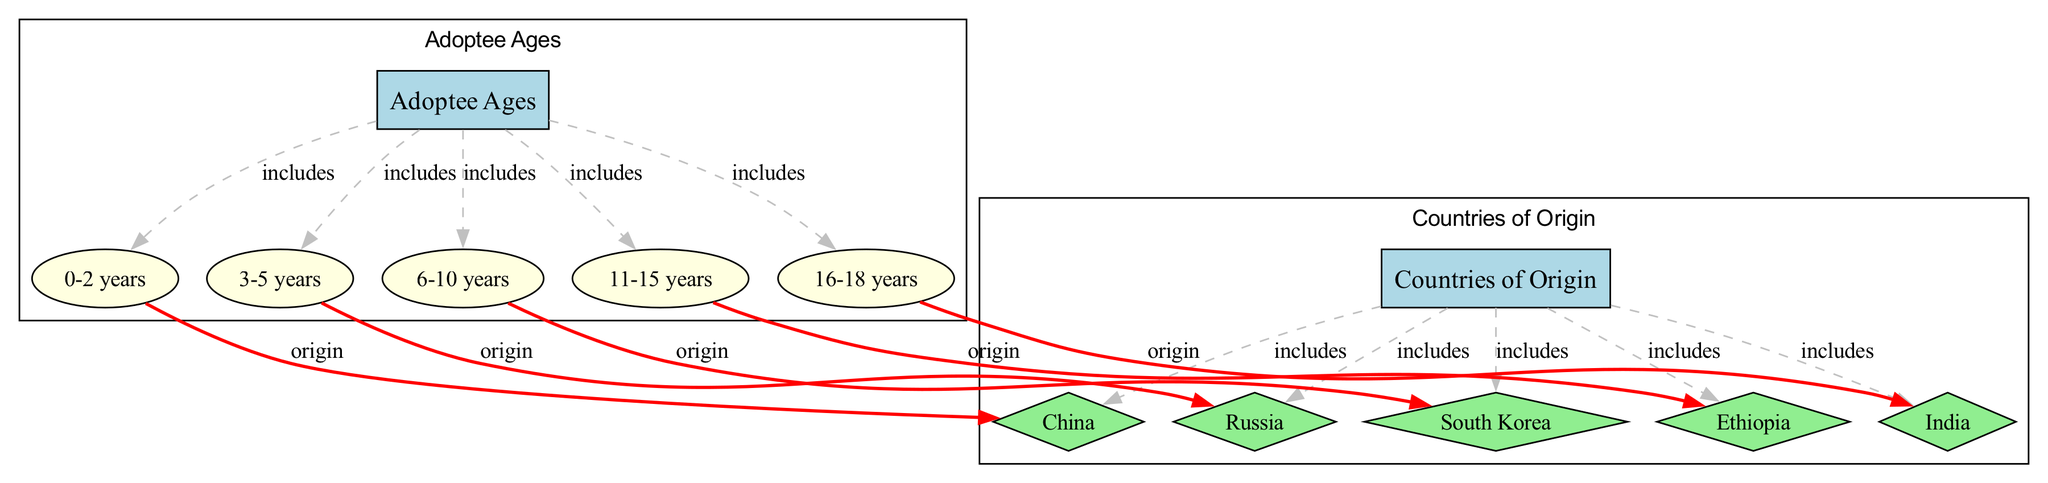what are the age groups of adoptees represented in the diagram? The diagram includes several nodes under the "Adoptee Ages" category. These nodes are "0-2 years," "3-5 years," "6-10 years," "11-15 years," and "16-18 years." Each of these age ranges indicates a specific cohort of adoptees.
Answer: 0-2 years, 3-5 years, 6-10 years, 11-15 years, 16-18 years how many countries of origin are depicted in the diagram? In the diagram, there are five nodes listed under the "Countries of Origin" category: "China," "Russia," "South Korea," "Ethiopia," and "India." Each node represents a distinct country that has been the origin for adoptees over the past 20 years.
Answer: 5 which age group does Ethiopia primarily correspond to in the diagram? The diagram indicates that Ethiopia corresponds primarily to the "11-15 years" age group. This is determined by examining the edges, specifically the edge labeled "origin" linking the age group "11-15 years" to the country "Ethiopia."
Answer: 11-15 years what color is used to represent the nodes for countries of origin? The nodes representing countries of origin in the diagram are colored light green. This color is specifically used for the nodes labeled as countries, distinguishing them from age groups and categories in the diagram.
Answer: light green which age group has the highest adoption originating from China according to the diagram? The diagram shows that the age group "0-2 years" is linked to the country "China" with an "origin" edge, indicating that this age group has the highest adoption rate from this specific country over the last 20 years.
Answer: 0-2 years how many edges are there between age groups and countries of origin in the diagram? To find the total edge count between age groups and countries of origin, we review all the "origin" edges in the diagram. There are a total of five edges connecting age groups to their respective countries, reflecting the relationships shown.
Answer: 5 which age group is associated with South Korea in the diagram? Upon analyzing the edges, "South Korea" is associated with the "6-10 years" age group, as indicated by the origin edge connecting these two nodes in the diagram.
Answer: 6-10 years which category includes the age range of "16-18 years"? The age range "16-18 years" is included in the "Adoptee Ages" category in the diagram. This categorization is identified by following the edge connection from the category node to the specific age group node.
Answer: Adoptee Ages 